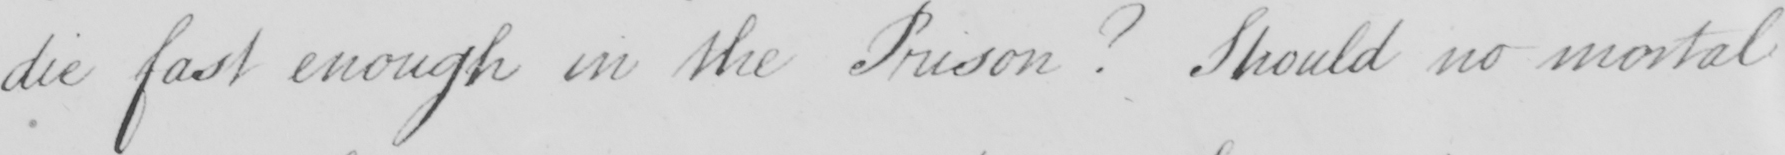Can you read and transcribe this handwriting? die fast enough in the Prison  ?  Should no mortal 